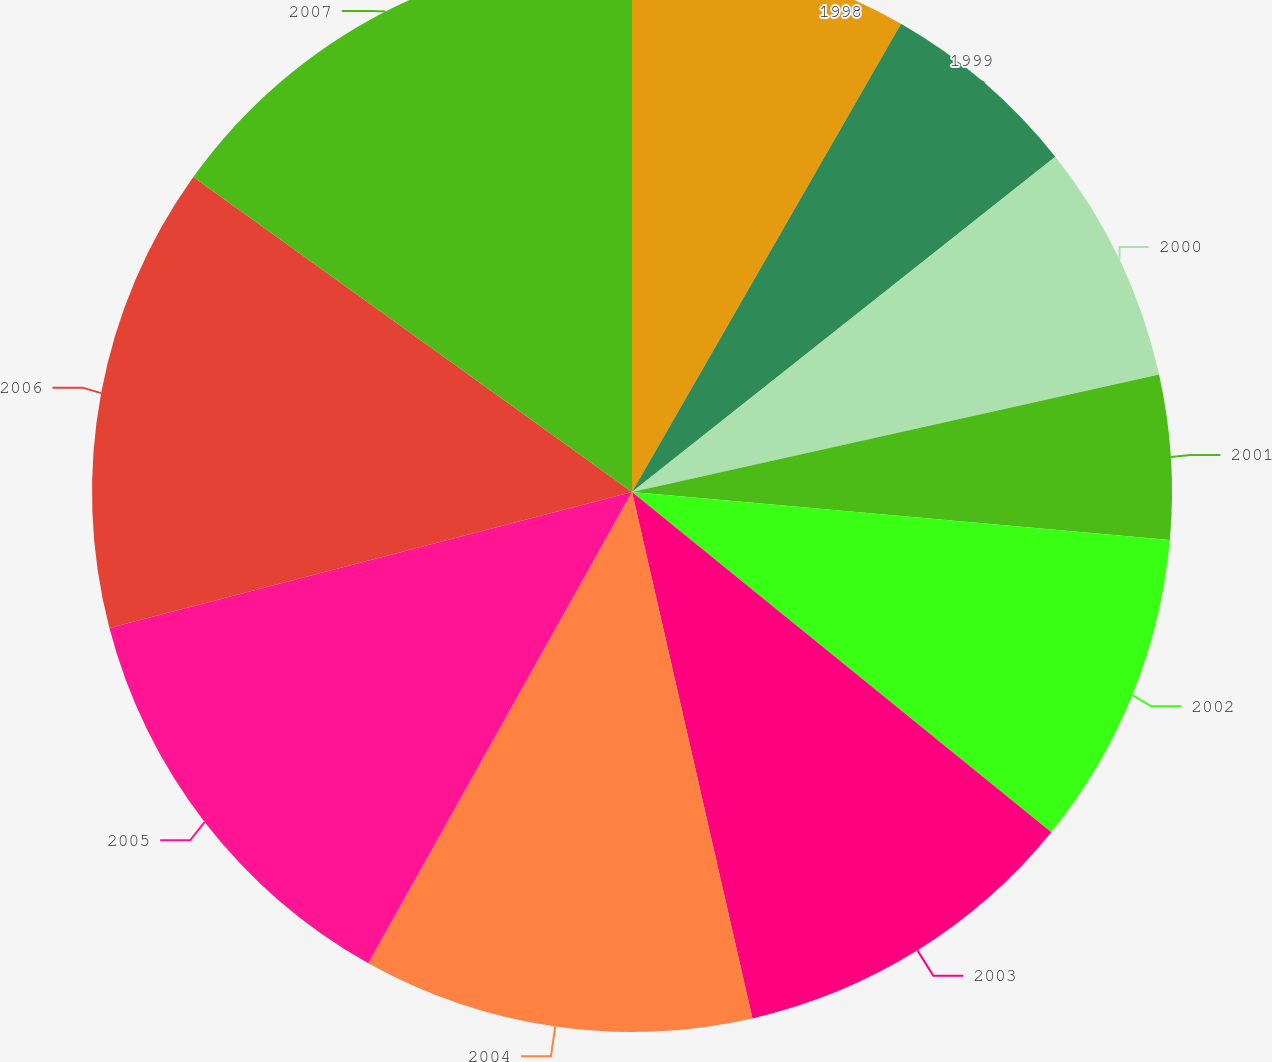Convert chart. <chart><loc_0><loc_0><loc_500><loc_500><pie_chart><fcel>1998<fcel>1999<fcel>2000<fcel>2001<fcel>2002<fcel>2003<fcel>2004<fcel>2005<fcel>2006<fcel>2007<nl><fcel>8.3%<fcel>6.04%<fcel>7.17%<fcel>4.91%<fcel>9.43%<fcel>10.57%<fcel>11.7%<fcel>12.83%<fcel>13.96%<fcel>15.09%<nl></chart> 